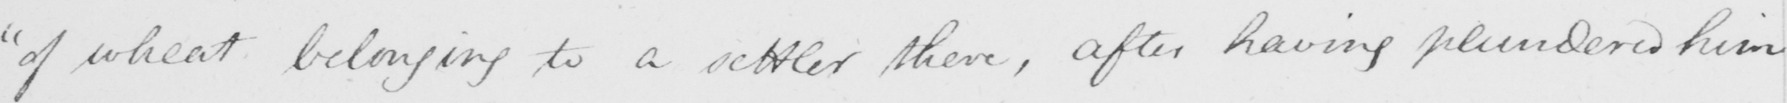What does this handwritten line say? " of wheat belonging to a settler there , after having plundered him 